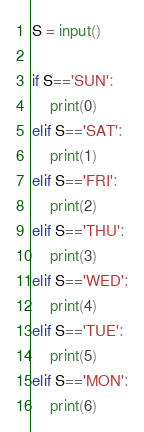Convert code to text. <code><loc_0><loc_0><loc_500><loc_500><_Python_>S = input()

if S=='SUN':
    print(0)
elif S=='SAT':
    print(1)
elif S=='FRI':
    print(2)   
elif S=='THU':
    print(3)
elif S=='WED':
    print(4)
elif S=='TUE':
    print(5)
elif S=='MON':
    print(6)    </code> 